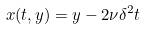<formula> <loc_0><loc_0><loc_500><loc_500>x ( t , y ) = y - 2 \nu \delta ^ { 2 } t</formula> 